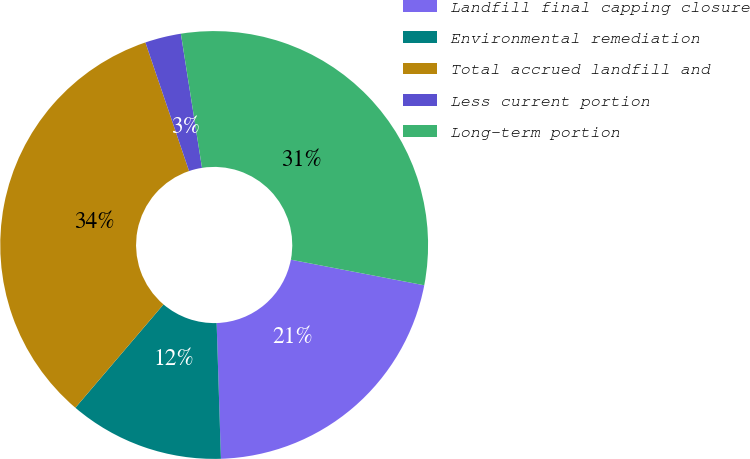Convert chart to OTSL. <chart><loc_0><loc_0><loc_500><loc_500><pie_chart><fcel>Landfill final capping closure<fcel>Environmental remediation<fcel>Total accrued landfill and<fcel>Less current portion<fcel>Long-term portion<nl><fcel>21.48%<fcel>11.74%<fcel>33.55%<fcel>2.72%<fcel>30.5%<nl></chart> 